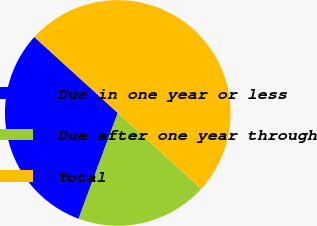Convert chart to OTSL. <chart><loc_0><loc_0><loc_500><loc_500><pie_chart><fcel>Due in one year or less<fcel>Due after one year through<fcel>Total<nl><fcel>31.1%<fcel>18.9%<fcel>50.0%<nl></chart> 